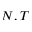Convert formula to latex. <formula><loc_0><loc_0><loc_500><loc_500>N , T</formula> 